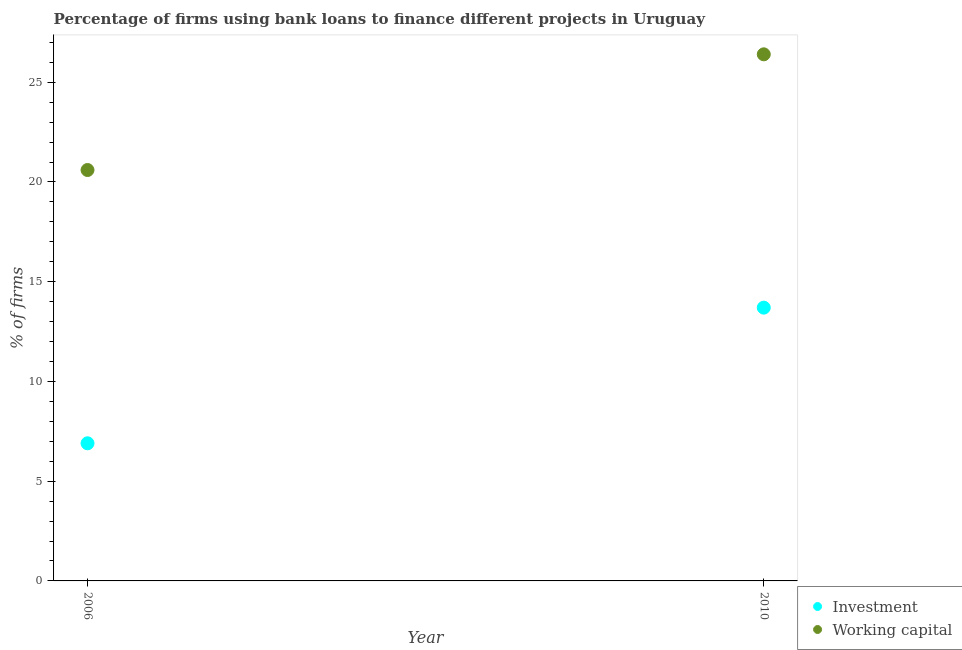How many different coloured dotlines are there?
Offer a very short reply. 2. Is the number of dotlines equal to the number of legend labels?
Offer a terse response. Yes. What is the percentage of firms using banks to finance working capital in 2010?
Give a very brief answer. 26.4. Across all years, what is the maximum percentage of firms using banks to finance working capital?
Keep it short and to the point. 26.4. Across all years, what is the minimum percentage of firms using banks to finance working capital?
Your response must be concise. 20.6. In which year was the percentage of firms using banks to finance working capital minimum?
Keep it short and to the point. 2006. What is the total percentage of firms using banks to finance investment in the graph?
Your response must be concise. 20.6. What is the difference between the percentage of firms using banks to finance working capital in 2006 and that in 2010?
Make the answer very short. -5.8. In the year 2006, what is the difference between the percentage of firms using banks to finance working capital and percentage of firms using banks to finance investment?
Give a very brief answer. 13.7. In how many years, is the percentage of firms using banks to finance investment greater than 19 %?
Give a very brief answer. 0. What is the ratio of the percentage of firms using banks to finance investment in 2006 to that in 2010?
Provide a succinct answer. 0.5. Is the percentage of firms using banks to finance investment strictly greater than the percentage of firms using banks to finance working capital over the years?
Your answer should be very brief. No. How many years are there in the graph?
Provide a short and direct response. 2. Are the values on the major ticks of Y-axis written in scientific E-notation?
Your response must be concise. No. Does the graph contain any zero values?
Your answer should be very brief. No. How many legend labels are there?
Provide a succinct answer. 2. How are the legend labels stacked?
Give a very brief answer. Vertical. What is the title of the graph?
Your response must be concise. Percentage of firms using bank loans to finance different projects in Uruguay. What is the label or title of the Y-axis?
Offer a very short reply. % of firms. What is the % of firms in Investment in 2006?
Make the answer very short. 6.9. What is the % of firms in Working capital in 2006?
Provide a succinct answer. 20.6. What is the % of firms of Working capital in 2010?
Your answer should be compact. 26.4. Across all years, what is the maximum % of firms in Investment?
Ensure brevity in your answer.  13.7. Across all years, what is the maximum % of firms in Working capital?
Make the answer very short. 26.4. Across all years, what is the minimum % of firms of Working capital?
Ensure brevity in your answer.  20.6. What is the total % of firms in Investment in the graph?
Your response must be concise. 20.6. What is the total % of firms of Working capital in the graph?
Your response must be concise. 47. What is the difference between the % of firms in Investment in 2006 and the % of firms in Working capital in 2010?
Your answer should be compact. -19.5. In the year 2006, what is the difference between the % of firms of Investment and % of firms of Working capital?
Your answer should be compact. -13.7. In the year 2010, what is the difference between the % of firms in Investment and % of firms in Working capital?
Keep it short and to the point. -12.7. What is the ratio of the % of firms of Investment in 2006 to that in 2010?
Give a very brief answer. 0.5. What is the ratio of the % of firms of Working capital in 2006 to that in 2010?
Ensure brevity in your answer.  0.78. What is the difference between the highest and the lowest % of firms in Investment?
Keep it short and to the point. 6.8. What is the difference between the highest and the lowest % of firms of Working capital?
Keep it short and to the point. 5.8. 